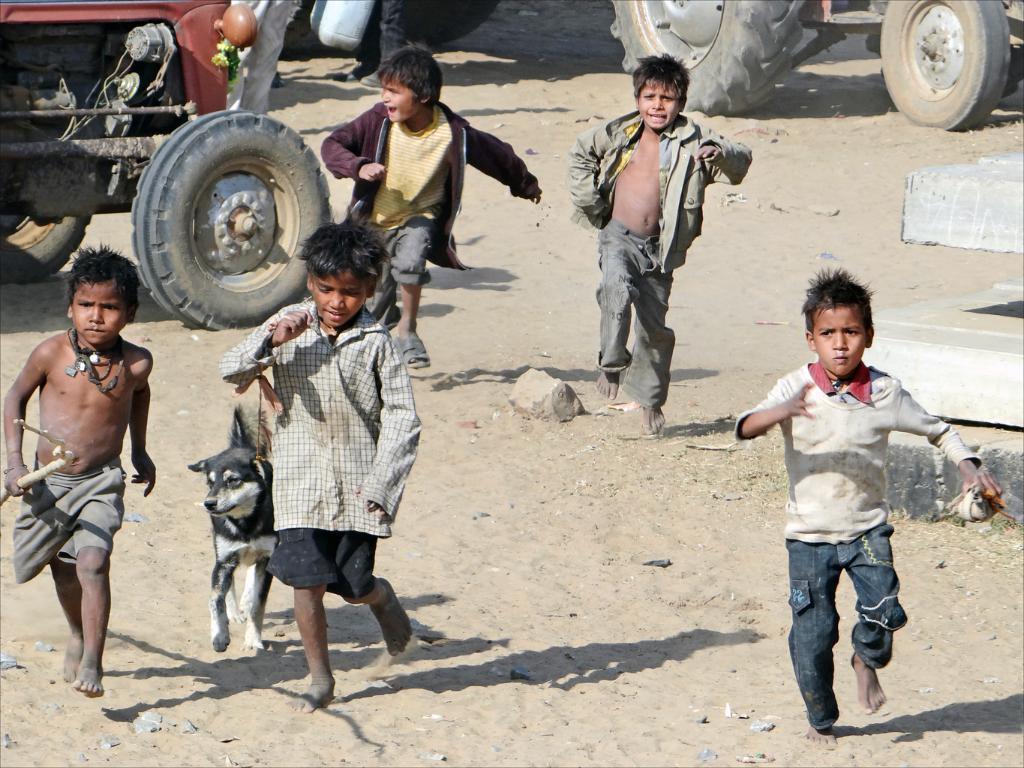Please provide a concise description of this image. In this picture we can see five boys running, dog, vehicles, stones on the ground and some objects. 